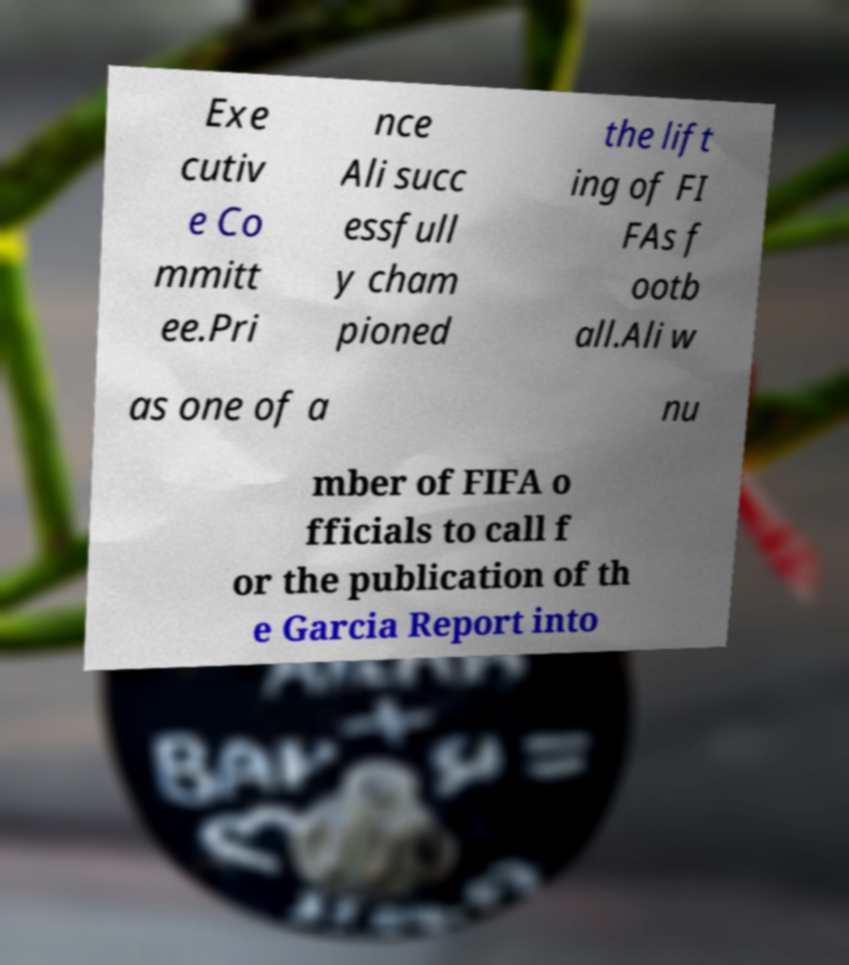Please identify and transcribe the text found in this image. Exe cutiv e Co mmitt ee.Pri nce Ali succ essfull y cham pioned the lift ing of FI FAs f ootb all.Ali w as one of a nu mber of FIFA o fficials to call f or the publication of th e Garcia Report into 